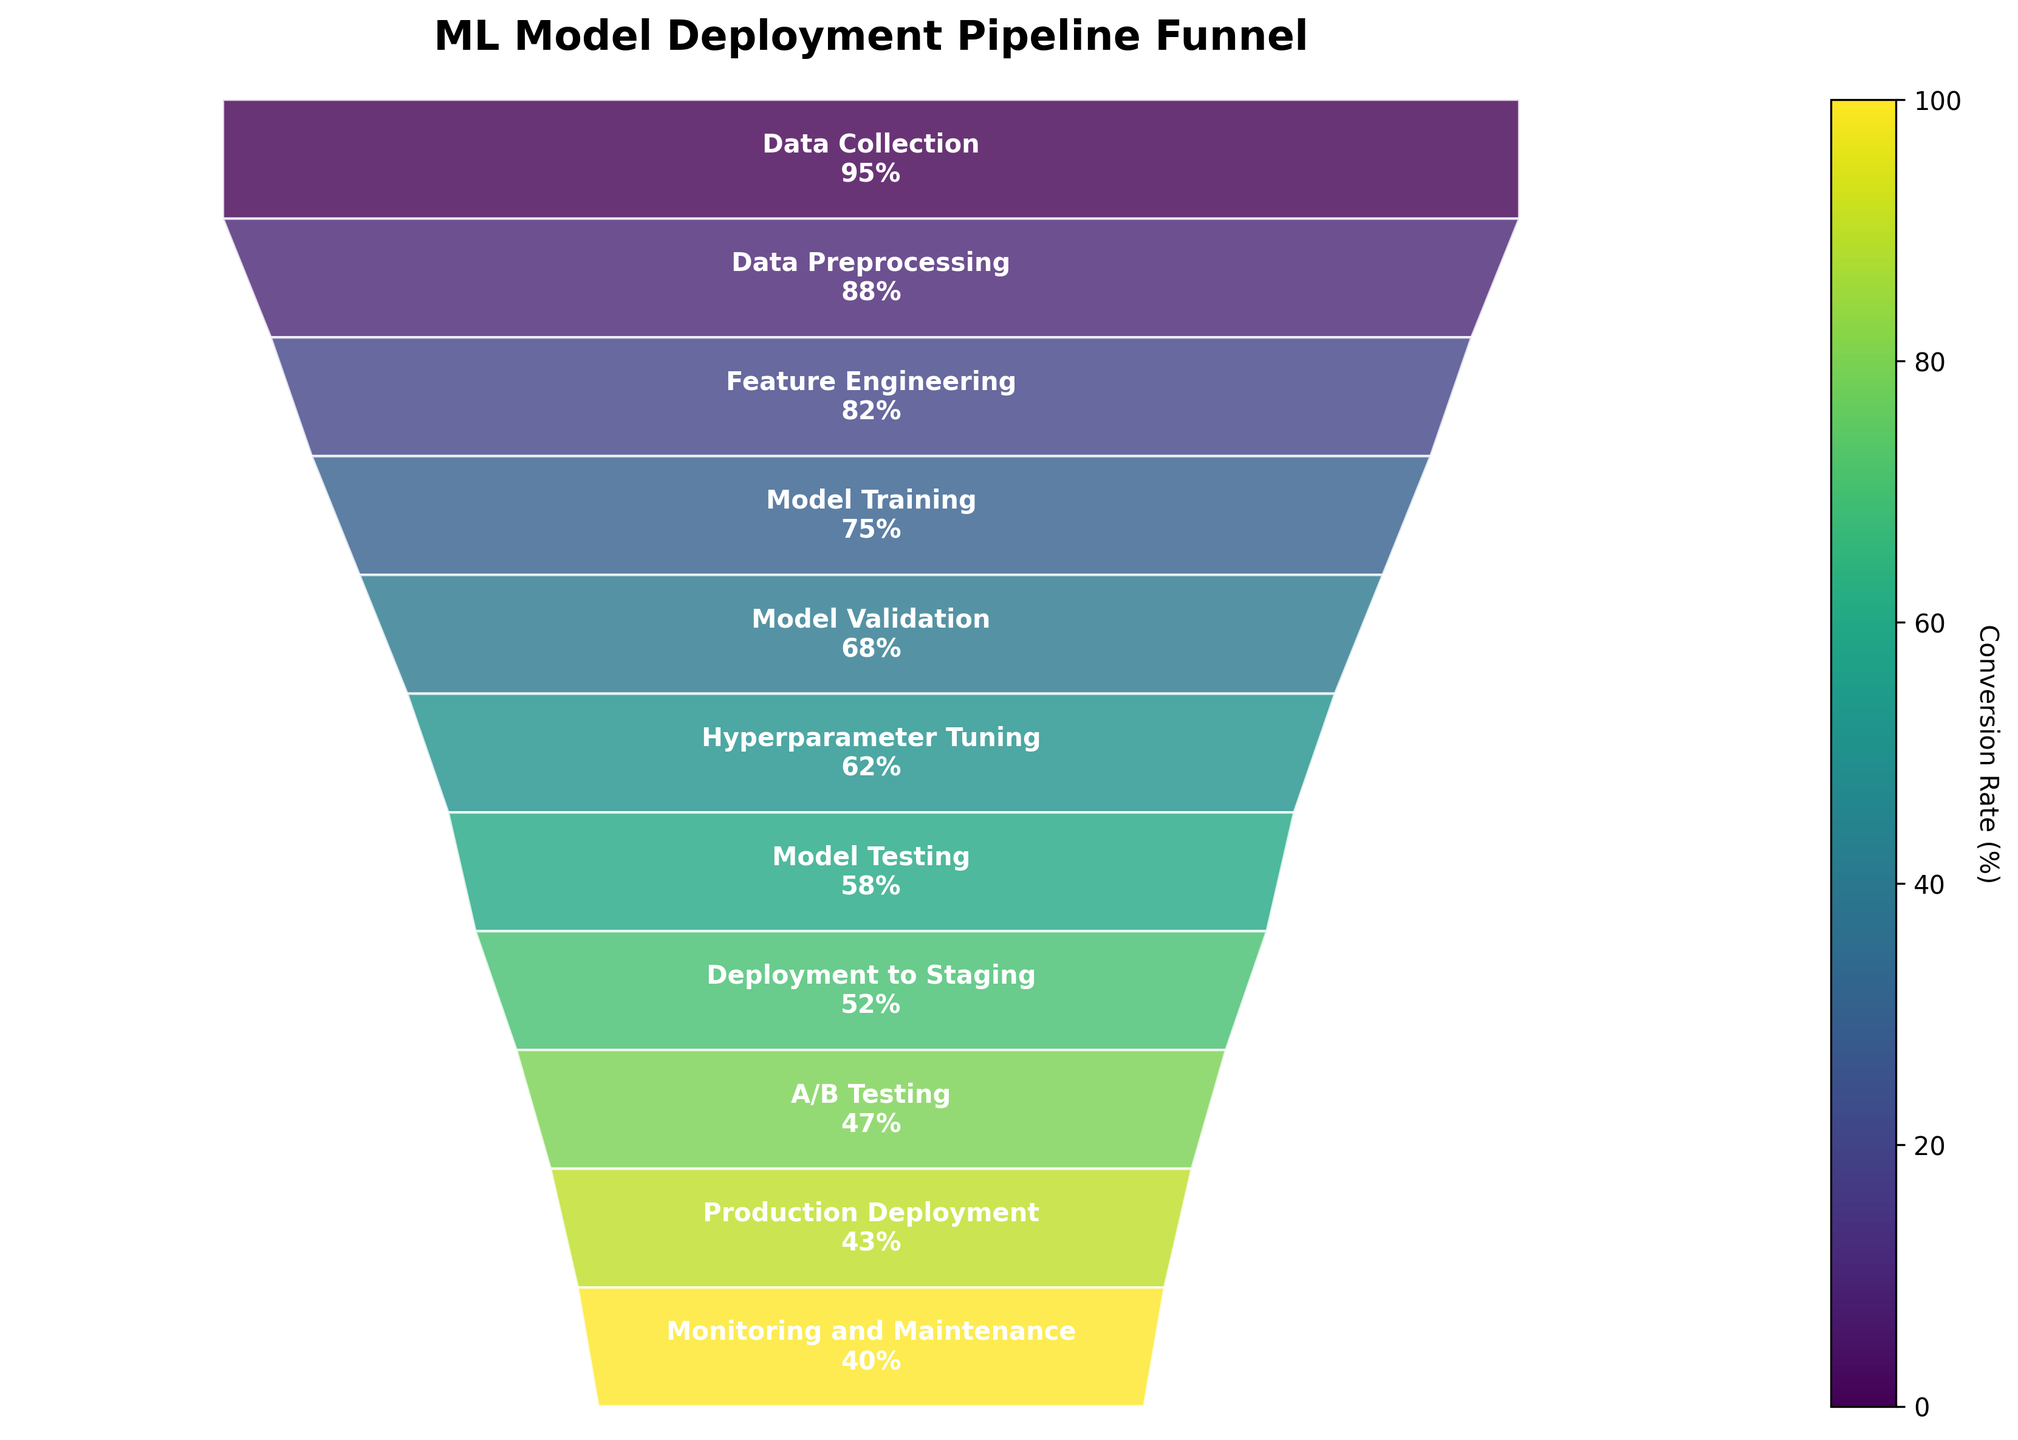What is the conversion rate at the "Model Training" stage? The funnel chart shows the conversion rate for each stage in the machine learning pipeline. By locating the "Model Training" stage on the chart, we see that it has a conversion rate mentioned within the funnel segment.
Answer: 75% How many stages in the pipeline have a conversion rate greater than 50%? To find this, count the number of stages listed in the chart which have a conversion rate above 50%.
Answer: 8 Which stage has the highest conversion rate? The stage with the highest conversion rate will be at the top of the funnel chart since stages are listed in descending order of conversion rates. The topmost stage is "Data Collection."
Answer: Data Collection What is the difference in conversion rates between "Model Validation" and "Hyperparameter Tuning"? First, find the conversion rates for "Model Validation" (68%) and "Hyperparameter Tuning" (62%). Then subtract the lower rate from the higher one. 68% - 62% = 6%
Answer: 6% Compare the conversion rates between "Deployment to Staging" and "A/B Testing". Which one is higher? Locate both stages in the funnel chart and compare their conversion rates. "Deployment to Staging" has 52%, and "A/B Testing" has 47%. Therefore, "Deployment to Staging" is higher.
Answer: Deployment to Staging What is the average conversion rate of the first three stages? The first three stages are "Data Collection" (95%), "Data Preprocessing" (88%), and "Feature Engineering" (82%). Calculate the average: (95% + 88% + 82%) / 3 = 88.33%
Answer: 88.33% At which stage does the conversion rate first drop below 60%? Start from the top and move down until you find the first stage where the conversion rate is below 60%. This happens at the "Model Testing" stage, which has a conversion rate of 58%.
Answer: Model Testing How does the conversion rate change from "Hyperparameter Tuning" to "Monitoring and Maintenance"? Note down the conversion rates: "Hyperparameter Tuning" (62%), "Model Testing" (58%), "Deployment to Staging" (52%), "A/B Testing" (47%), "Production Deployment" (43%), and “Monitoring and Maintenance” (40%). Observe that the conversion rate decreases gradually at each step down the funnel.
Answer: Gradually decreases What is the sum of the conversion rates for "Feature Engineering" and "A/B Testing"? Locate the conversion rates for "Feature Engineering" (82%) and "A/B Testing" (47%). Add them together: 82% + 47% = 129%.
Answer: 129% Which stages have a narrower width compared to "Model Training"? Compare the widths illustrated in the funnel chart. Stages below "Model Training" will have narrower widths since the conversion rate at "Model Training" is higher than those stages. These stages are "Model Validation," "Hyperparameter Tuning," "Model Testing," "Deployment to Staging," "A/B Testing," "Production Deployment," and "Monitoring and Maintenance."
Answer: Model Validation, Hyperparameter Tuning, Model Testing, Deployment to Staging, A/B Testing, Production Deployment, Monitoring and Maintenance 